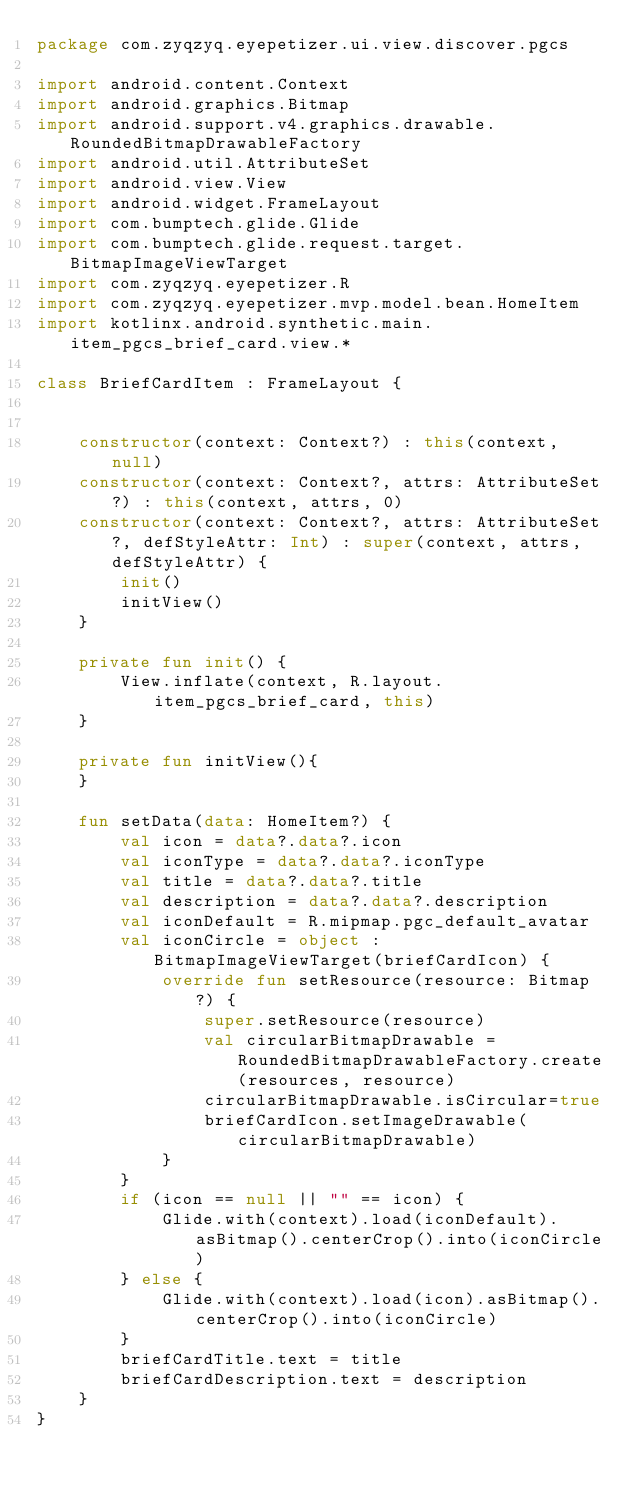<code> <loc_0><loc_0><loc_500><loc_500><_Kotlin_>package com.zyqzyq.eyepetizer.ui.view.discover.pgcs

import android.content.Context
import android.graphics.Bitmap
import android.support.v4.graphics.drawable.RoundedBitmapDrawableFactory
import android.util.AttributeSet
import android.view.View
import android.widget.FrameLayout
import com.bumptech.glide.Glide
import com.bumptech.glide.request.target.BitmapImageViewTarget
import com.zyqzyq.eyepetizer.R
import com.zyqzyq.eyepetizer.mvp.model.bean.HomeItem
import kotlinx.android.synthetic.main.item_pgcs_brief_card.view.*

class BriefCardItem : FrameLayout {


    constructor(context: Context?) : this(context, null)
    constructor(context: Context?, attrs: AttributeSet?) : this(context, attrs, 0)
    constructor(context: Context?, attrs: AttributeSet?, defStyleAttr: Int) : super(context, attrs, defStyleAttr) {
        init()
        initView()
    }

    private fun init() {
        View.inflate(context, R.layout.item_pgcs_brief_card, this)
    }

    private fun initView(){
    }

    fun setData(data: HomeItem?) {
        val icon = data?.data?.icon
        val iconType = data?.data?.iconType
        val title = data?.data?.title
        val description = data?.data?.description
        val iconDefault = R.mipmap.pgc_default_avatar
        val iconCircle = object : BitmapImageViewTarget(briefCardIcon) {
            override fun setResource(resource: Bitmap?) {
                super.setResource(resource)
                val circularBitmapDrawable = RoundedBitmapDrawableFactory.create(resources, resource)
                circularBitmapDrawable.isCircular=true
                briefCardIcon.setImageDrawable(circularBitmapDrawable)
            }
        }
        if (icon == null || "" == icon) {
            Glide.with(context).load(iconDefault).asBitmap().centerCrop().into(iconCircle)
        } else {
            Glide.with(context).load(icon).asBitmap().centerCrop().into(iconCircle)
        }
        briefCardTitle.text = title
        briefCardDescription.text = description
    }
}</code> 